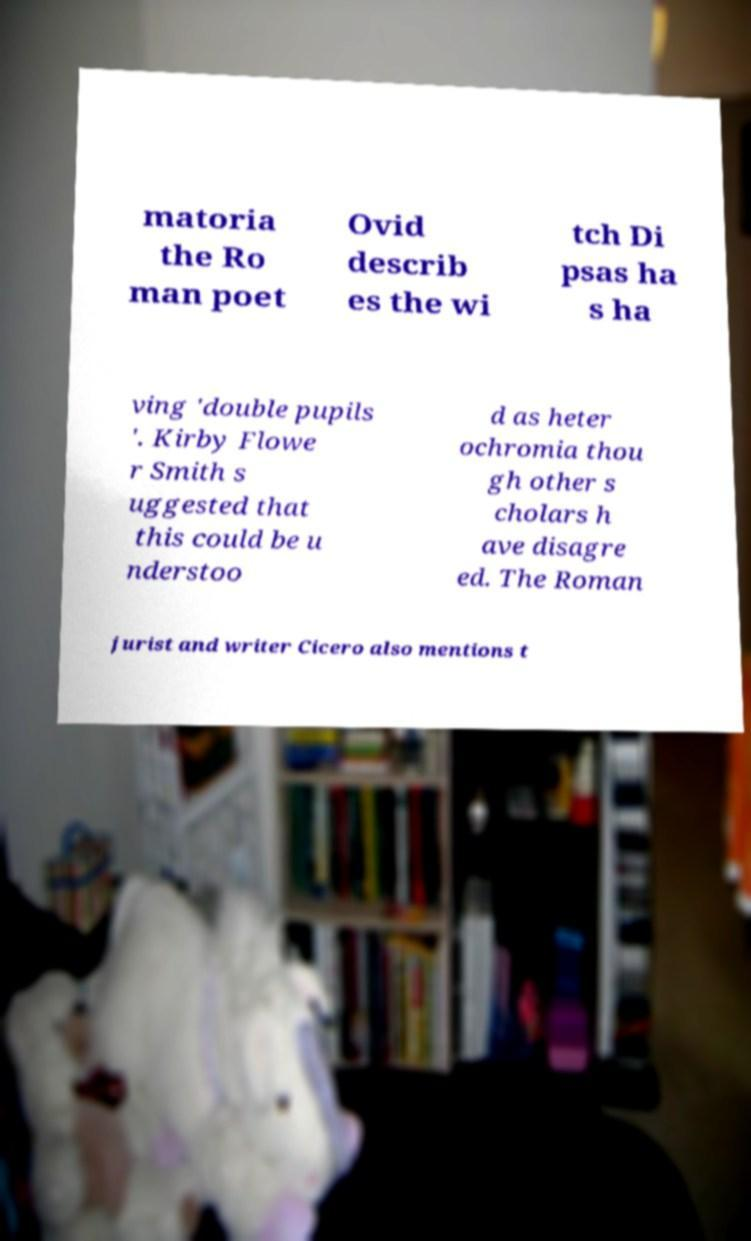Please read and relay the text visible in this image. What does it say? matoria the Ro man poet Ovid describ es the wi tch Di psas ha s ha ving 'double pupils '. Kirby Flowe r Smith s uggested that this could be u nderstoo d as heter ochromia thou gh other s cholars h ave disagre ed. The Roman jurist and writer Cicero also mentions t 